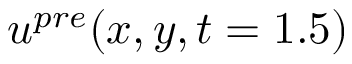Convert formula to latex. <formula><loc_0><loc_0><loc_500><loc_500>u ^ { p r e } ( x , y , t = 1 . 5 )</formula> 